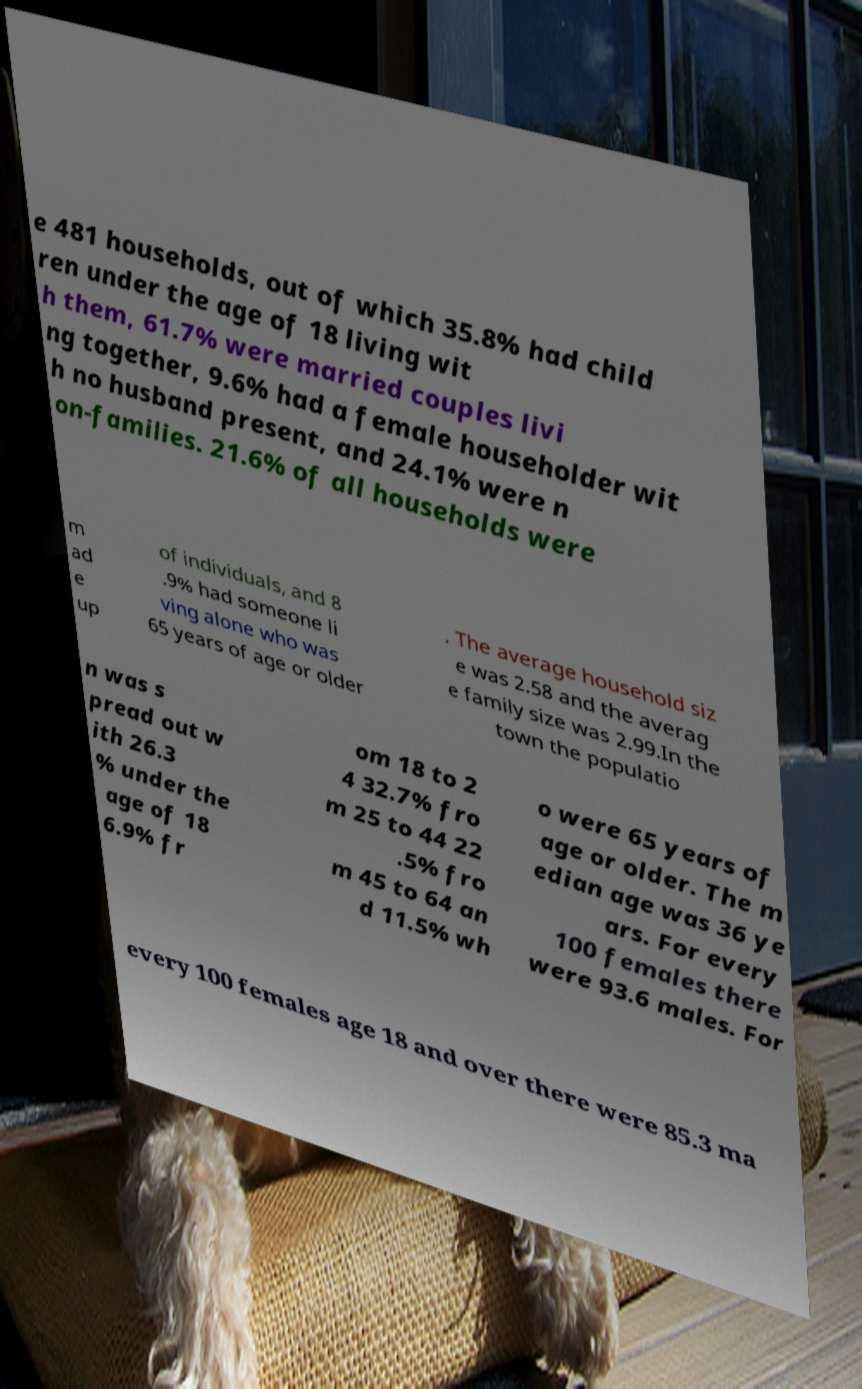There's text embedded in this image that I need extracted. Can you transcribe it verbatim? e 481 households, out of which 35.8% had child ren under the age of 18 living wit h them, 61.7% were married couples livi ng together, 9.6% had a female householder wit h no husband present, and 24.1% were n on-families. 21.6% of all households were m ad e up of individuals, and 8 .9% had someone li ving alone who was 65 years of age or older . The average household siz e was 2.58 and the averag e family size was 2.99.In the town the populatio n was s pread out w ith 26.3 % under the age of 18 6.9% fr om 18 to 2 4 32.7% fro m 25 to 44 22 .5% fro m 45 to 64 an d 11.5% wh o were 65 years of age or older. The m edian age was 36 ye ars. For every 100 females there were 93.6 males. For every 100 females age 18 and over there were 85.3 ma 